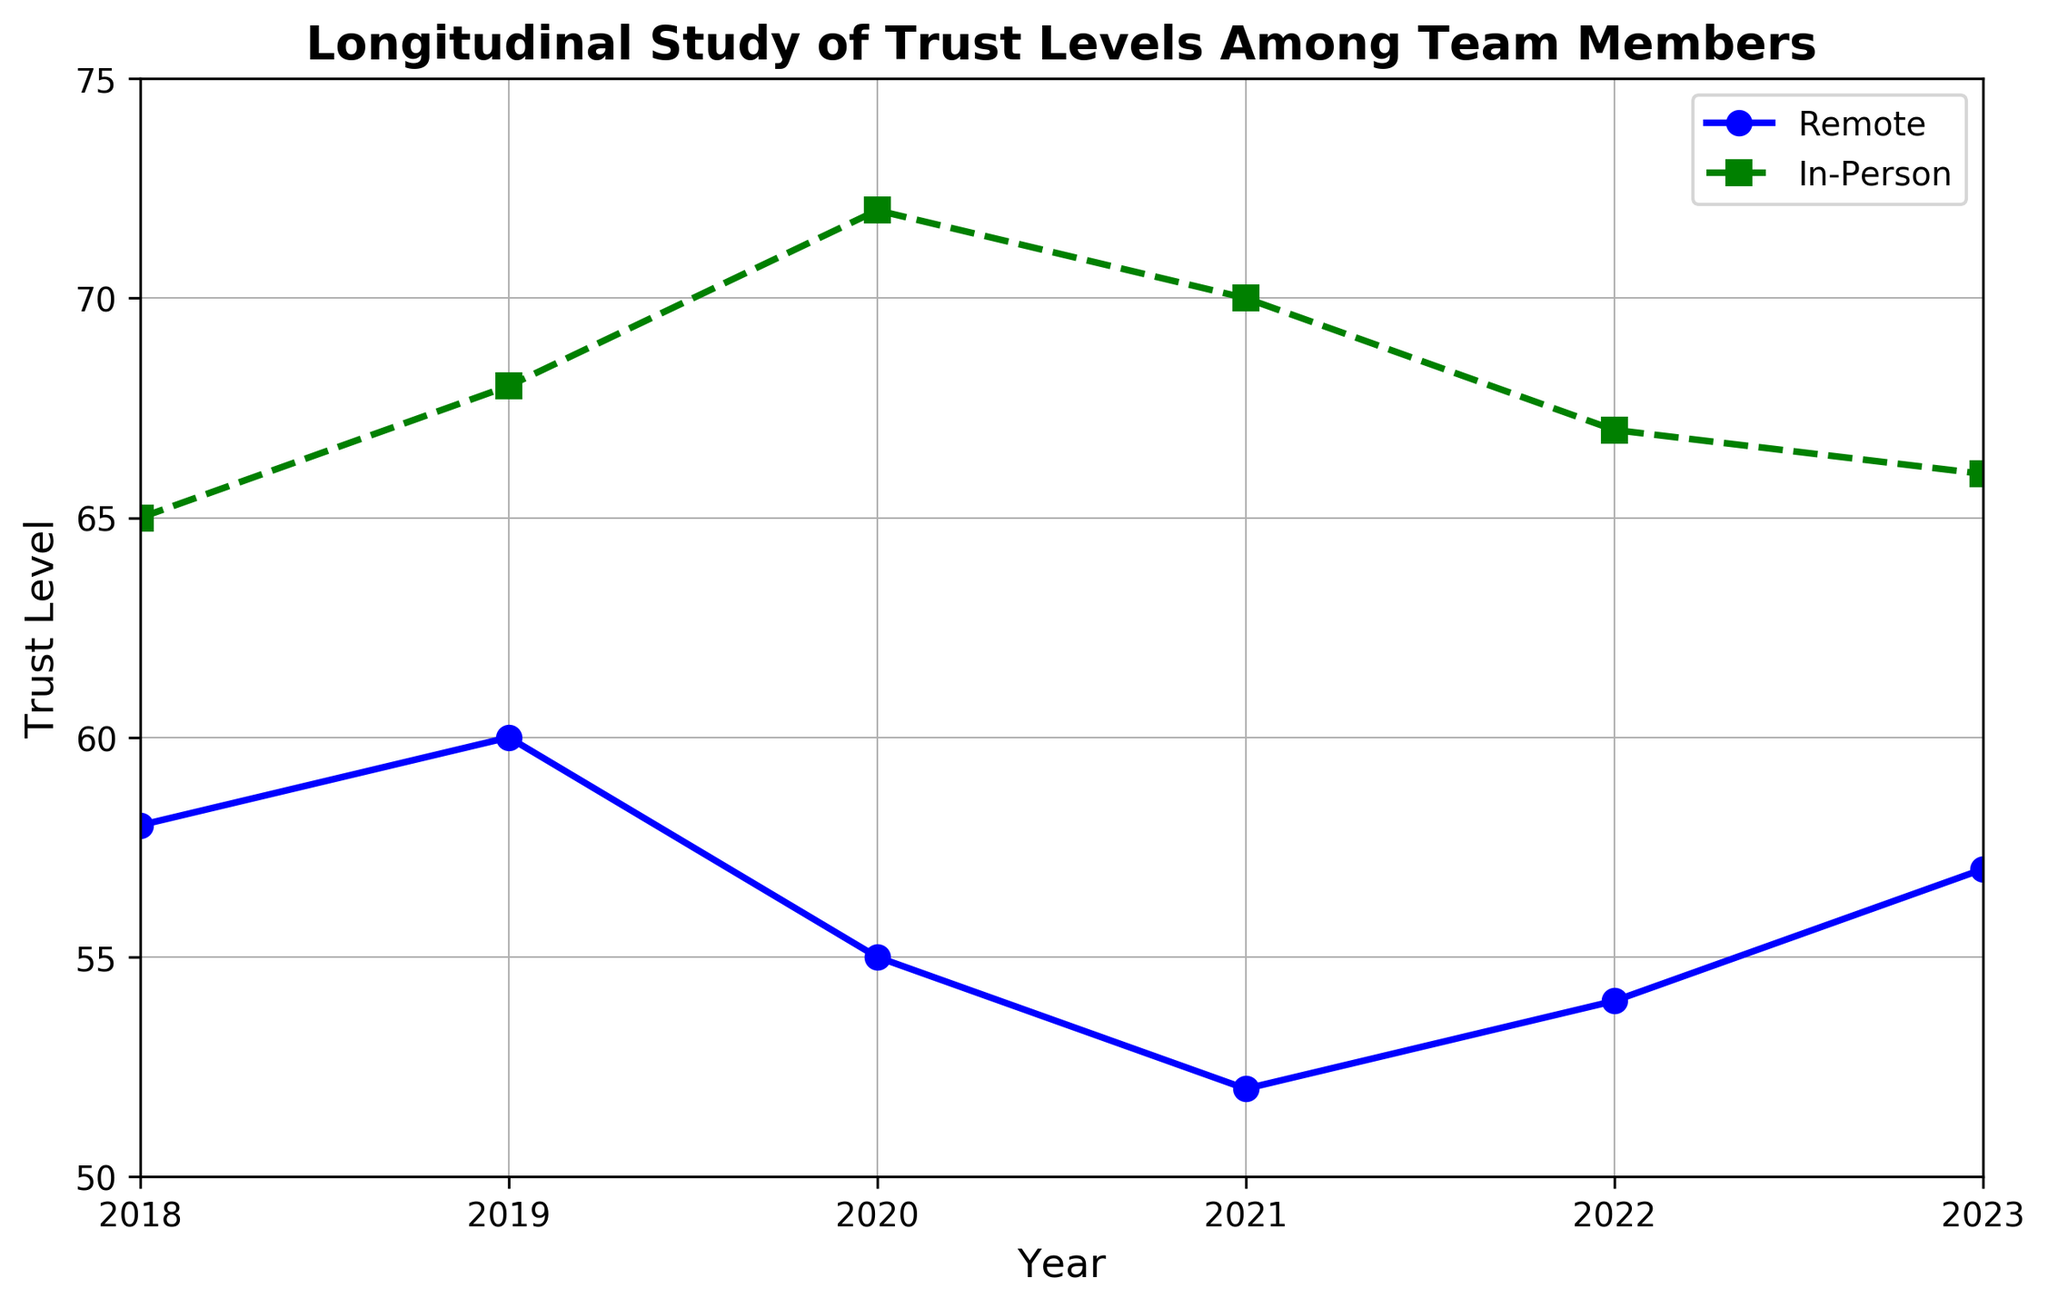What's the trend of trust levels in remote settings from 2018 to 2023? The trust level in remote settings in 2018 was 58. It increased to 60 in 2019, decreased to 55 in 2020, further decreased to 52 in 2021, then increased to 54 in 2022, and finally increased to 57 in 2023. Overall, the trend shows fluctuations with an initial increase, followed by a decrease, and then a slight recovery towards 2023.
Answer: Fluctuating with initial increase, then decrease, and slight recovery In which year was the difference in trust levels between in-person and remote settings the greatest? To find this, we calculate the absolute difference in trust levels for each year: 2018: 65 - 58 = 7, 2019: 68 - 60 = 8, 2020: 72 - 55 = 17, 2021: 70 - 52 = 18, 2022: 67 - 54 = 13, and 2023: 66 - 57 = 9. The greatest difference occurs in 2021 (18).
Answer: 2021 In which year were the trust levels in remote settings the lowest? By checking the data points for remote settings, the lowest trust level is 52, which occurred in 2021.
Answer: 2021 Compare the trend of trust levels for in-person and remote settings over the years. Observing the trends for both settings, the in-person setting shows an overall higher trust level with slight fluctuations. Trust in-person increased steadily from 65 in 2018 to 72 in 2020, slightly dipped to 70 in 2021, decreased again to 67 in 2022, and then to 66 in 2023. The remote setting shows more significant fluctuations, with an initial rise to 60 in 2019, a drop to 55 in 2020, further decreased to 52 in 2021, then a slight recovery to 54 in 2022, and up to 57 in 2023. Overall, in-person trust has remained more stable compared to remote.
Answer: In-person more stable, remote fluctuated more What was the average trust level for remote settings from 2018 to 2023? Average can be found by summing the trust levels for remote settings from 2018 to 2023 and then dividing by the number of years: (58 + 60 + 55 + 52 + 54 + 57) / 6 = 336 / 6 = 56.
Answer: 56 During which years did the trust level in remote settings increase, and by how much? The trust level increased in 2019 (58 to 60), 2022 (54 to 57), and 2023 (54 to 57). The increases are: 2019: 60 - 58 = 2, 2022: 54 - 52 = 2, and 2023: 57 - 54 = 3.
Answer: 2019 (2), 2022 (2), 2023 (3) In which year did the trust levels in remote and in-person settings both decrease? By examining the data, trust levels in both settings decreased in 2021: remote from 55 to 52 and in-person from 70 to 67.
Answer: 2021 What is the average difference in trust levels between in-person and remote settings over the given years? To find this, first calculate the difference for each year and then average them: (7 + 8 + 17 + 18 + 13 + 9) / 6 = 72 / 6 = 12.
Answer: 12 What was the maximum trust level recorded for in-person settings and in which year? Observing the in-person data, the maximum trust level is 72, which occurred in 2020.
Answer: 72, 2020 